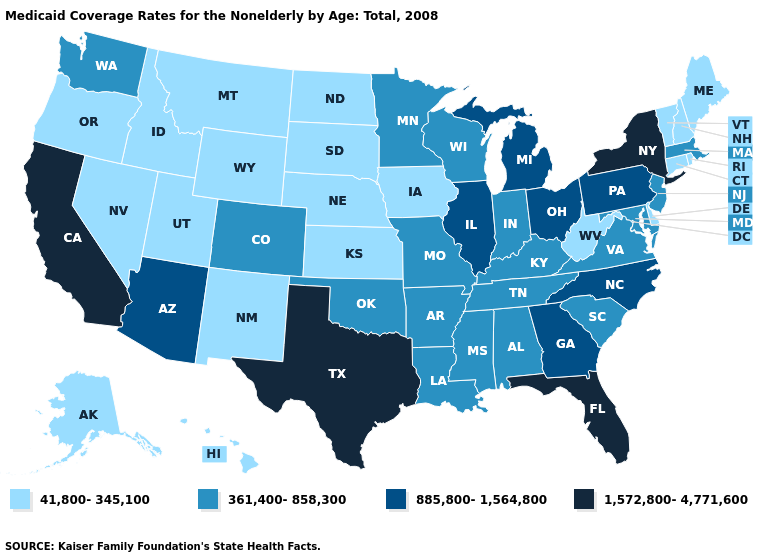Among the states that border Massachusetts , which have the lowest value?
Write a very short answer. Connecticut, New Hampshire, Rhode Island, Vermont. Does New Jersey have the same value as Texas?
Write a very short answer. No. Among the states that border Ohio , does Michigan have the highest value?
Answer briefly. Yes. Is the legend a continuous bar?
Answer briefly. No. Does Minnesota have the same value as Alabama?
Quick response, please. Yes. What is the value of West Virginia?
Keep it brief. 41,800-345,100. Name the states that have a value in the range 885,800-1,564,800?
Be succinct. Arizona, Georgia, Illinois, Michigan, North Carolina, Ohio, Pennsylvania. What is the lowest value in the USA?
Quick response, please. 41,800-345,100. What is the lowest value in states that border Arkansas?
Write a very short answer. 361,400-858,300. Name the states that have a value in the range 41,800-345,100?
Answer briefly. Alaska, Connecticut, Delaware, Hawaii, Idaho, Iowa, Kansas, Maine, Montana, Nebraska, Nevada, New Hampshire, New Mexico, North Dakota, Oregon, Rhode Island, South Dakota, Utah, Vermont, West Virginia, Wyoming. Does Maine have the lowest value in the USA?
Concise answer only. Yes. What is the lowest value in states that border New Mexico?
Short answer required. 41,800-345,100. What is the lowest value in states that border Florida?
Quick response, please. 361,400-858,300. Name the states that have a value in the range 361,400-858,300?
Give a very brief answer. Alabama, Arkansas, Colorado, Indiana, Kentucky, Louisiana, Maryland, Massachusetts, Minnesota, Mississippi, Missouri, New Jersey, Oklahoma, South Carolina, Tennessee, Virginia, Washington, Wisconsin. What is the value of Maryland?
Keep it brief. 361,400-858,300. 